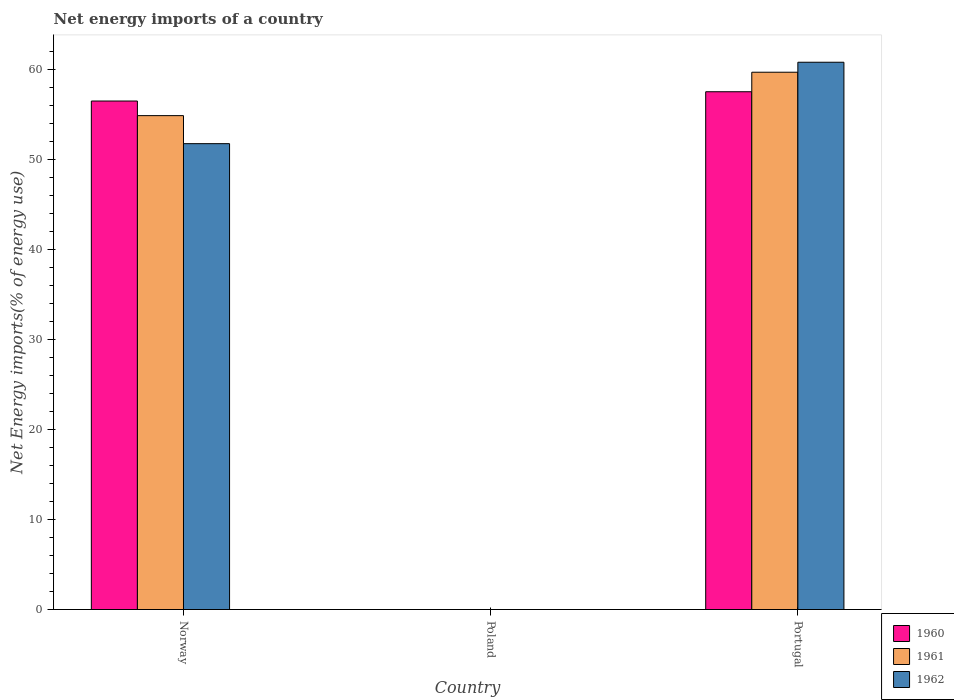How many bars are there on the 1st tick from the left?
Your response must be concise. 3. What is the label of the 2nd group of bars from the left?
Ensure brevity in your answer.  Poland. What is the net energy imports in 1960 in Poland?
Offer a very short reply. 0. Across all countries, what is the maximum net energy imports in 1962?
Keep it short and to the point. 60.85. What is the total net energy imports in 1962 in the graph?
Give a very brief answer. 112.65. What is the difference between the net energy imports in 1962 in Norway and that in Portugal?
Provide a short and direct response. -9.05. What is the difference between the net energy imports in 1960 in Norway and the net energy imports in 1961 in Portugal?
Keep it short and to the point. -3.2. What is the average net energy imports in 1960 per country?
Give a very brief answer. 38.04. What is the difference between the net energy imports of/in 1962 and net energy imports of/in 1960 in Norway?
Offer a very short reply. -4.74. What is the ratio of the net energy imports in 1961 in Norway to that in Portugal?
Provide a succinct answer. 0.92. Is the difference between the net energy imports in 1962 in Norway and Portugal greater than the difference between the net energy imports in 1960 in Norway and Portugal?
Give a very brief answer. No. What is the difference between the highest and the lowest net energy imports in 1961?
Offer a very short reply. 59.74. Is the sum of the net energy imports in 1962 in Norway and Portugal greater than the maximum net energy imports in 1960 across all countries?
Your answer should be compact. Yes. Are all the bars in the graph horizontal?
Your answer should be compact. No. Does the graph contain grids?
Provide a short and direct response. No. Where does the legend appear in the graph?
Your answer should be very brief. Bottom right. How are the legend labels stacked?
Provide a short and direct response. Vertical. What is the title of the graph?
Your answer should be very brief. Net energy imports of a country. Does "2003" appear as one of the legend labels in the graph?
Provide a short and direct response. No. What is the label or title of the X-axis?
Ensure brevity in your answer.  Country. What is the label or title of the Y-axis?
Your response must be concise. Net Energy imports(% of energy use). What is the Net Energy imports(% of energy use) of 1960 in Norway?
Your answer should be compact. 56.54. What is the Net Energy imports(% of energy use) of 1961 in Norway?
Make the answer very short. 54.92. What is the Net Energy imports(% of energy use) in 1962 in Norway?
Your answer should be very brief. 51.8. What is the Net Energy imports(% of energy use) in 1961 in Poland?
Your answer should be compact. 0. What is the Net Energy imports(% of energy use) of 1960 in Portugal?
Offer a very short reply. 57.57. What is the Net Energy imports(% of energy use) in 1961 in Portugal?
Provide a short and direct response. 59.74. What is the Net Energy imports(% of energy use) of 1962 in Portugal?
Make the answer very short. 60.85. Across all countries, what is the maximum Net Energy imports(% of energy use) in 1960?
Offer a terse response. 57.57. Across all countries, what is the maximum Net Energy imports(% of energy use) in 1961?
Your response must be concise. 59.74. Across all countries, what is the maximum Net Energy imports(% of energy use) of 1962?
Ensure brevity in your answer.  60.85. Across all countries, what is the minimum Net Energy imports(% of energy use) of 1960?
Your answer should be compact. 0. What is the total Net Energy imports(% of energy use) in 1960 in the graph?
Provide a short and direct response. 114.12. What is the total Net Energy imports(% of energy use) of 1961 in the graph?
Provide a succinct answer. 114.66. What is the total Net Energy imports(% of energy use) in 1962 in the graph?
Offer a terse response. 112.65. What is the difference between the Net Energy imports(% of energy use) in 1960 in Norway and that in Portugal?
Your answer should be very brief. -1.03. What is the difference between the Net Energy imports(% of energy use) in 1961 in Norway and that in Portugal?
Ensure brevity in your answer.  -4.83. What is the difference between the Net Energy imports(% of energy use) in 1962 in Norway and that in Portugal?
Make the answer very short. -9.05. What is the difference between the Net Energy imports(% of energy use) in 1960 in Norway and the Net Energy imports(% of energy use) in 1961 in Portugal?
Your response must be concise. -3.2. What is the difference between the Net Energy imports(% of energy use) in 1960 in Norway and the Net Energy imports(% of energy use) in 1962 in Portugal?
Keep it short and to the point. -4.31. What is the difference between the Net Energy imports(% of energy use) in 1961 in Norway and the Net Energy imports(% of energy use) in 1962 in Portugal?
Your answer should be very brief. -5.94. What is the average Net Energy imports(% of energy use) of 1960 per country?
Offer a terse response. 38.04. What is the average Net Energy imports(% of energy use) of 1961 per country?
Offer a very short reply. 38.22. What is the average Net Energy imports(% of energy use) in 1962 per country?
Offer a very short reply. 37.55. What is the difference between the Net Energy imports(% of energy use) of 1960 and Net Energy imports(% of energy use) of 1961 in Norway?
Give a very brief answer. 1.62. What is the difference between the Net Energy imports(% of energy use) in 1960 and Net Energy imports(% of energy use) in 1962 in Norway?
Your response must be concise. 4.74. What is the difference between the Net Energy imports(% of energy use) of 1961 and Net Energy imports(% of energy use) of 1962 in Norway?
Your answer should be compact. 3.12. What is the difference between the Net Energy imports(% of energy use) in 1960 and Net Energy imports(% of energy use) in 1961 in Portugal?
Offer a very short reply. -2.17. What is the difference between the Net Energy imports(% of energy use) in 1960 and Net Energy imports(% of energy use) in 1962 in Portugal?
Give a very brief answer. -3.28. What is the difference between the Net Energy imports(% of energy use) in 1961 and Net Energy imports(% of energy use) in 1962 in Portugal?
Offer a terse response. -1.11. What is the ratio of the Net Energy imports(% of energy use) in 1960 in Norway to that in Portugal?
Keep it short and to the point. 0.98. What is the ratio of the Net Energy imports(% of energy use) in 1961 in Norway to that in Portugal?
Your answer should be very brief. 0.92. What is the ratio of the Net Energy imports(% of energy use) of 1962 in Norway to that in Portugal?
Offer a very short reply. 0.85. What is the difference between the highest and the lowest Net Energy imports(% of energy use) of 1960?
Give a very brief answer. 57.57. What is the difference between the highest and the lowest Net Energy imports(% of energy use) in 1961?
Your response must be concise. 59.74. What is the difference between the highest and the lowest Net Energy imports(% of energy use) in 1962?
Your answer should be very brief. 60.85. 